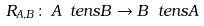<formula> <loc_0><loc_0><loc_500><loc_500>R _ { A , B } \colon \, A \ t e n s B \to B \ t e n s A</formula> 